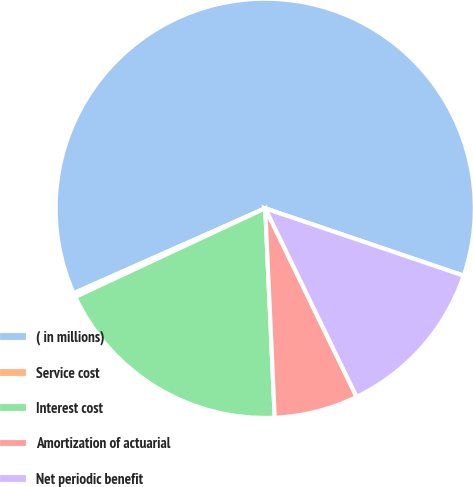<chart> <loc_0><loc_0><loc_500><loc_500><pie_chart><fcel>( in millions)<fcel>Service cost<fcel>Interest cost<fcel>Amortization of actuarial<fcel>Net periodic benefit<nl><fcel>61.85%<fcel>0.31%<fcel>18.77%<fcel>6.46%<fcel>12.61%<nl></chart> 